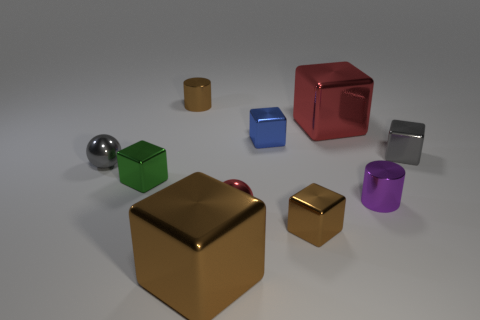Subtract 3 cubes. How many cubes are left? 3 Subtract all red blocks. How many blocks are left? 5 Subtract all tiny gray metallic blocks. How many blocks are left? 5 Subtract all red blocks. Subtract all cyan balls. How many blocks are left? 5 Subtract all balls. How many objects are left? 8 Subtract 0 cyan cylinders. How many objects are left? 10 Subtract all brown blocks. Subtract all big metallic cubes. How many objects are left? 6 Add 8 big red metal cubes. How many big red metal cubes are left? 9 Add 3 purple metal things. How many purple metal things exist? 4 